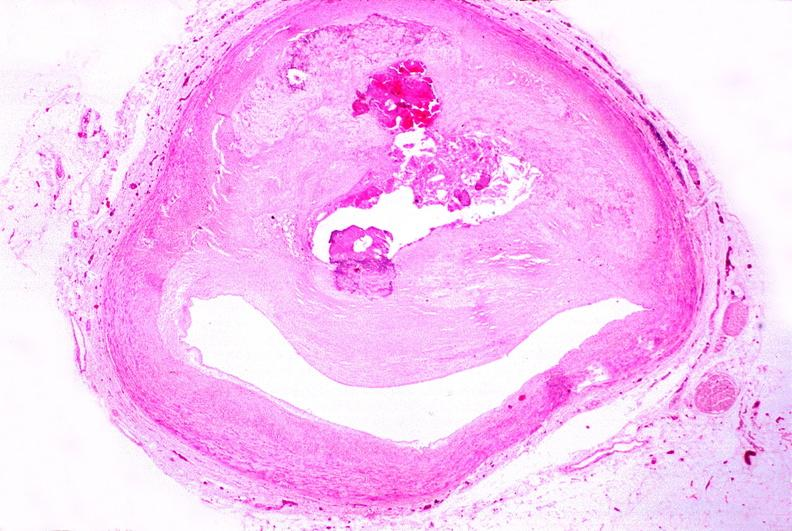how is atherosclerosis left anterior descending artery?
Answer the question using a single word or phrase. Coronary 